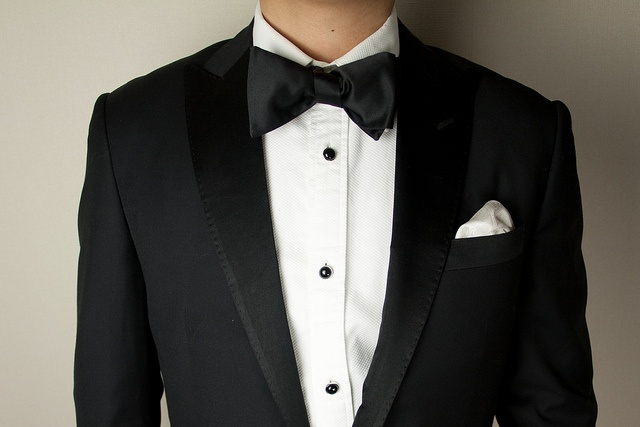Describe the objects in this image and their specific colors. I can see people in black, darkgray, white, and gray tones and tie in darkgray, black, gray, navy, and purple tones in this image. 